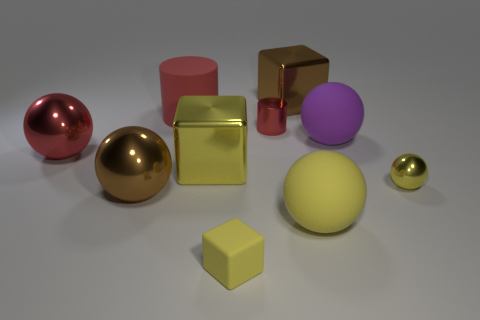There is a red rubber cylinder; is it the same size as the brown metallic thing that is behind the yellow metallic ball?
Give a very brief answer. Yes. There is a matte thing that is in front of the metal cylinder and to the left of the brown block; what is its size?
Your response must be concise. Small. Is there a large rubber cylinder that has the same color as the tiny shiny ball?
Your response must be concise. No. There is a metallic cube in front of the big block that is behind the red rubber object; what color is it?
Make the answer very short. Yellow. Are there fewer brown spheres that are on the left side of the big red metal ball than large purple things left of the small cylinder?
Make the answer very short. No. Do the yellow shiny block and the purple thing have the same size?
Your answer should be very brief. Yes. What shape is the metallic object that is to the left of the tiny matte object and on the right side of the matte cylinder?
Provide a short and direct response. Cube. How many tiny objects are made of the same material as the large red sphere?
Keep it short and to the point. 2. There is a shiny thing behind the big red rubber object; what number of large yellow spheres are on the left side of it?
Keep it short and to the point. 0. What shape is the large brown thing to the right of the big metal block in front of the red matte cylinder behind the metallic cylinder?
Ensure brevity in your answer.  Cube. 